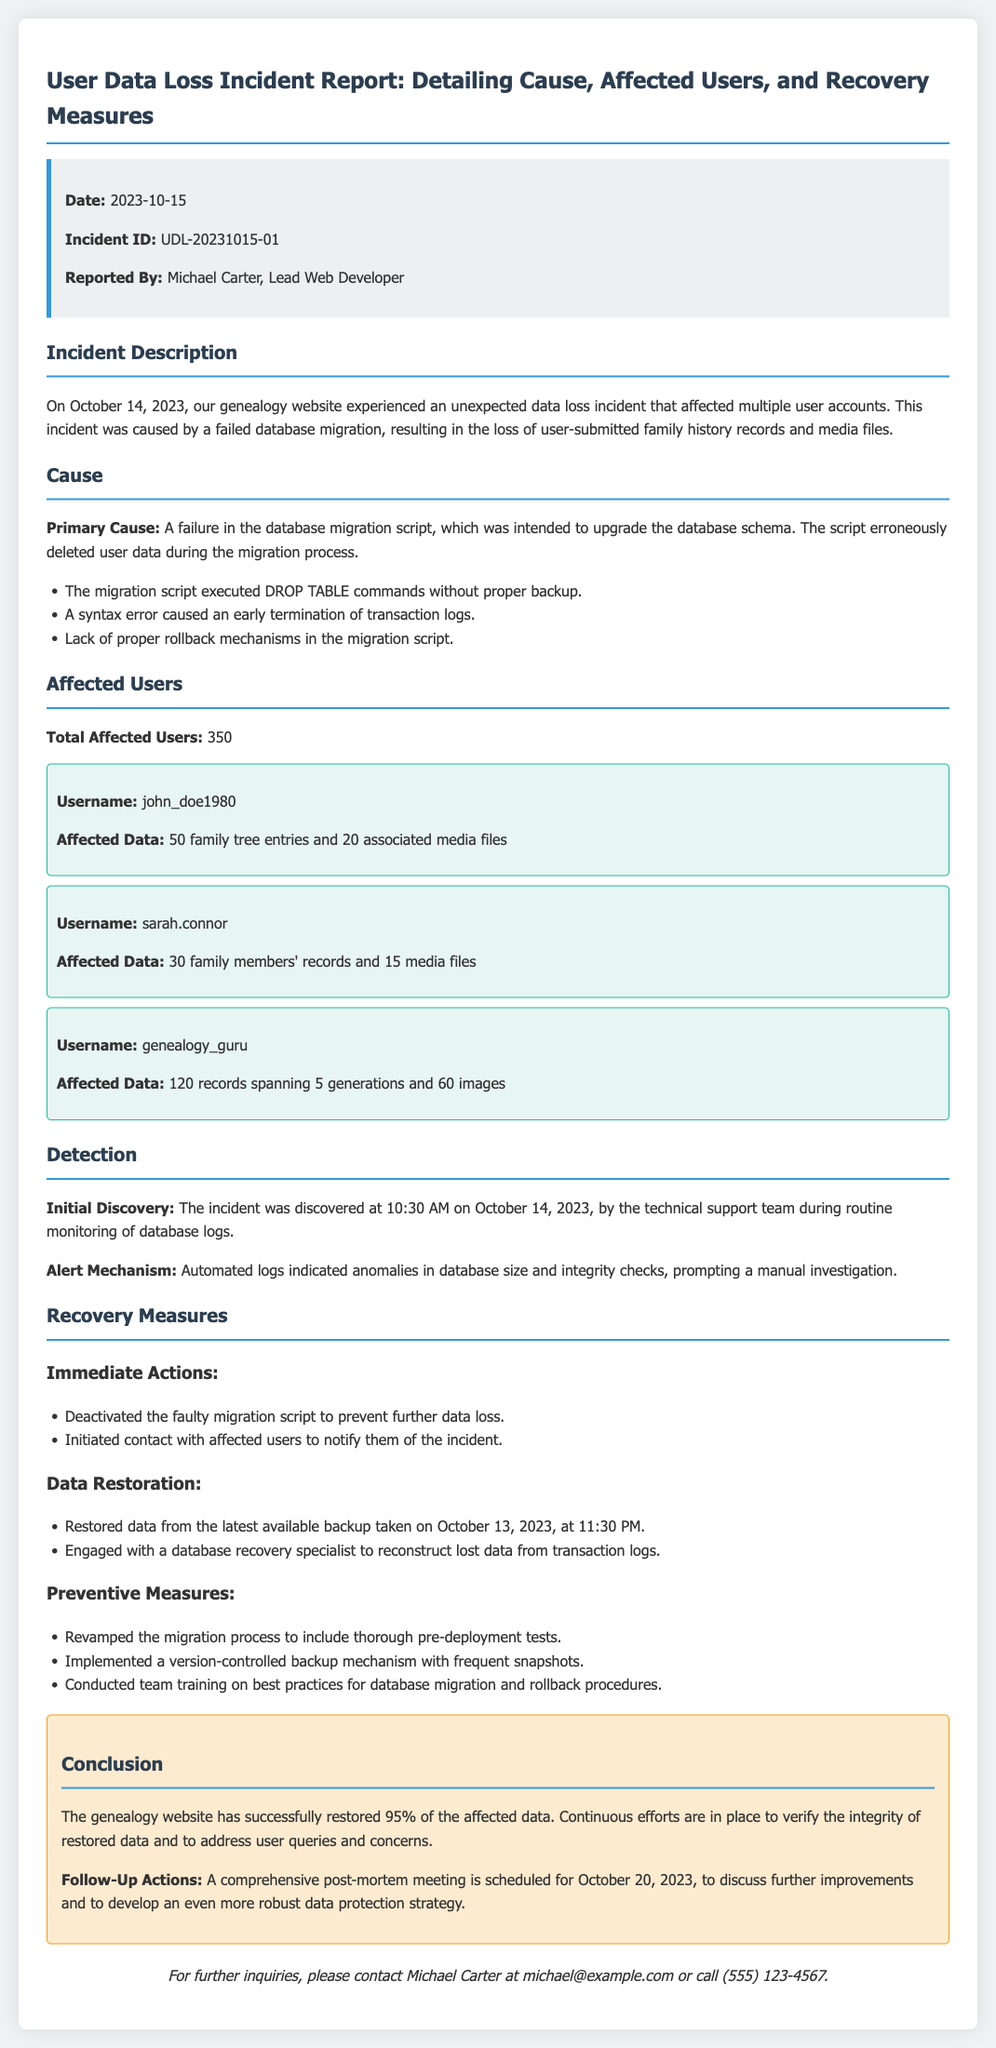What is the date of the incident? The date of the incident is mentioned in the incident report as October 14, 2023.
Answer: October 14, 2023 Who reported the incident? The report specifies that the incident was reported by Michael Carter, who is the Lead Web Developer.
Answer: Michael Carter How many total users were affected? The report indicates that a total of 350 users were affected by the data loss incident.
Answer: 350 What was the primary cause of the incident? The incident report states that the primary cause was a failure in the database migration script.
Answer: A failure in the database migration script What actions were taken immediately after the incident? The report lists immediate actions, including deactivating the faulty migration script and contacting affected users.
Answer: Deactivated the faulty migration script and contacted affected users What percentage of data was successfully restored? The report concludes that 95% of the affected data was successfully restored.
Answer: 95% When is the follow-up meeting scheduled? The document specifies that the follow-up meeting is scheduled for October 20, 2023.
Answer: October 20, 2023 What type of data was primarily lost? The report mentions that user-submitted family history records and media files were lost in the incident.
Answer: Family history records and media files What preventive measure was mentioned regarding migration processes? The report indicates that the migration process was revamped to include thorough pre-deployment tests.
Answer: Thorough pre-deployment tests 